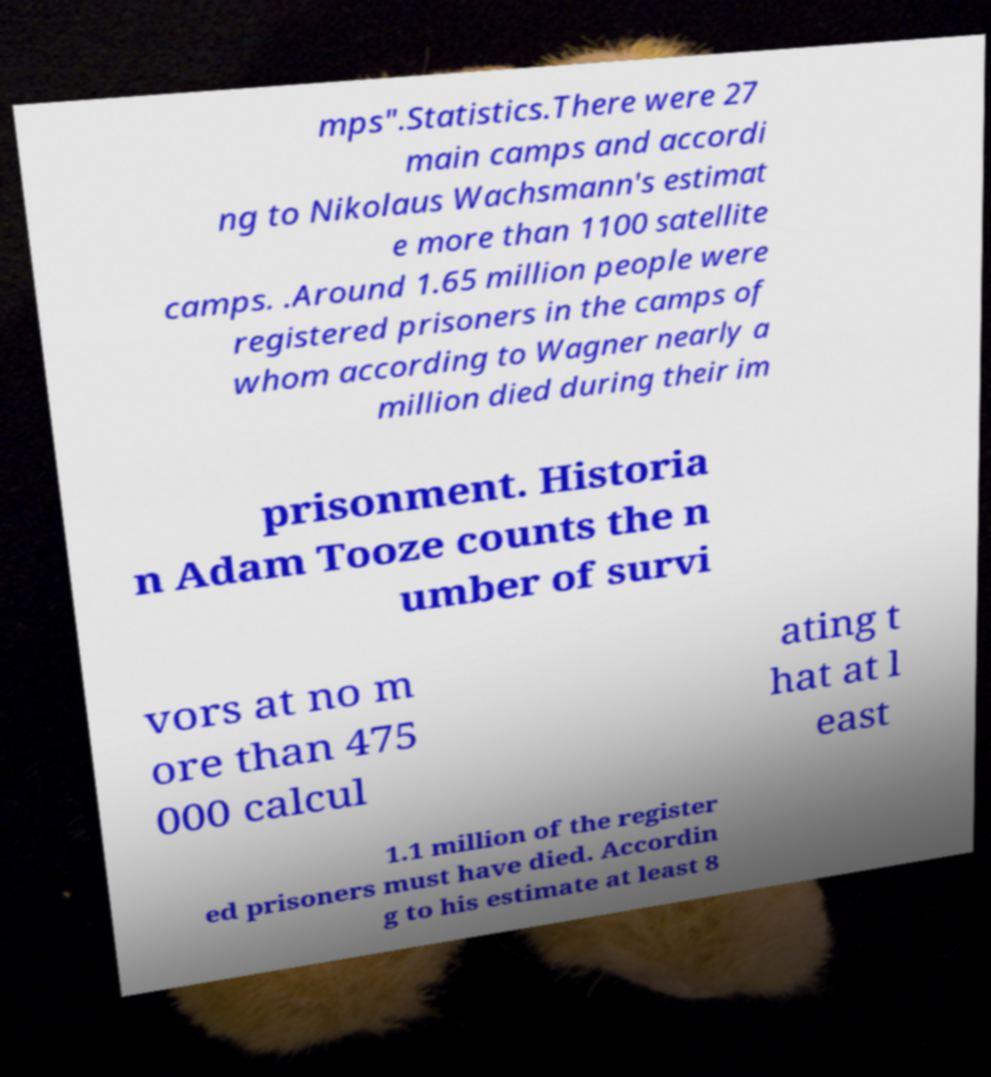Could you assist in decoding the text presented in this image and type it out clearly? mps".Statistics.There were 27 main camps and accordi ng to Nikolaus Wachsmann's estimat e more than 1100 satellite camps. .Around 1.65 million people were registered prisoners in the camps of whom according to Wagner nearly a million died during their im prisonment. Historia n Adam Tooze counts the n umber of survi vors at no m ore than 475 000 calcul ating t hat at l east 1.1 million of the register ed prisoners must have died. Accordin g to his estimate at least 8 